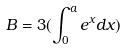Convert formula to latex. <formula><loc_0><loc_0><loc_500><loc_500>B = 3 ( \int _ { 0 } ^ { a } e ^ { x } d x )</formula> 